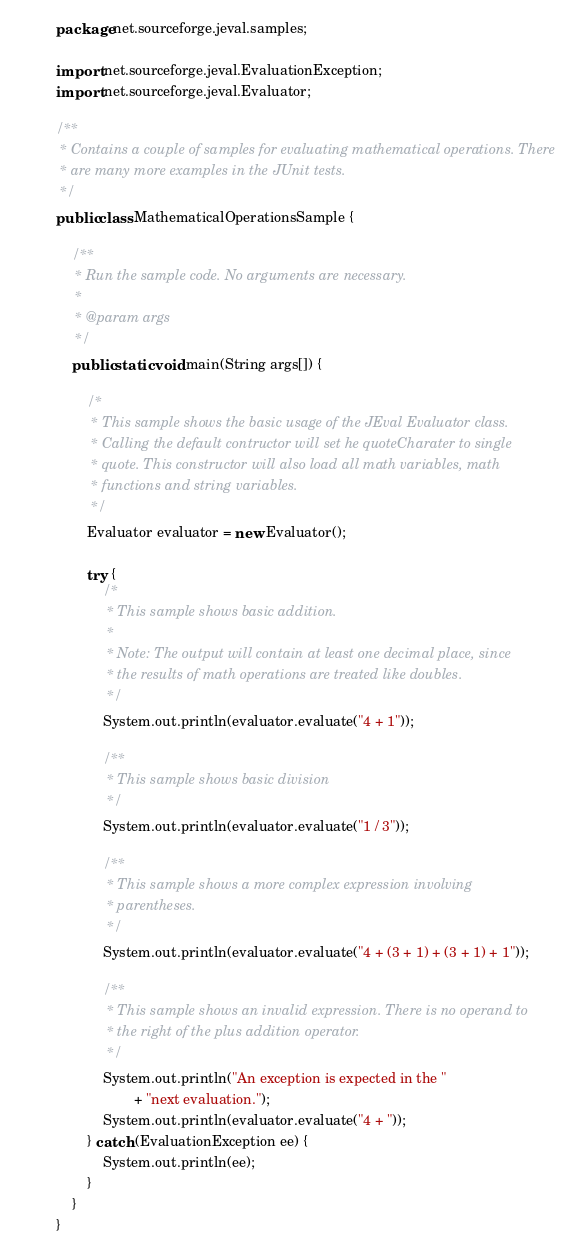Convert code to text. <code><loc_0><loc_0><loc_500><loc_500><_Java_>package net.sourceforge.jeval.samples;

import net.sourceforge.jeval.EvaluationException;
import net.sourceforge.jeval.Evaluator;

/**
 * Contains a couple of samples for evaluating mathematical operations. There
 * are many more examples in the JUnit tests.
 */
public class MathematicalOperationsSample {

	/**
	 * Run the sample code. No arguments are necessary.
	 * 
	 * @param args
	 */
	public static void main(String args[]) {

		/*
		 * This sample shows the basic usage of the JEval Evaluator class.
		 * Calling the default contructor will set he quoteCharater to single
		 * quote. This constructor will also load all math variables, math
		 * functions and string variables.
		 */
		Evaluator evaluator = new Evaluator();

		try {
			/*
			 * This sample shows basic addition.
			 * 
			 * Note: The output will contain at least one decimal place, since
			 * the results of math operations are treated like doubles.
			 */
			System.out.println(evaluator.evaluate("4 + 1"));

			/**
			 * This sample shows basic division
			 */
			System.out.println(evaluator.evaluate("1 / 3"));

			/**
			 * This sample shows a more complex expression involving
			 * parentheses.
			 */
			System.out.println(evaluator.evaluate("4 + (3 + 1) + (3 + 1) + 1"));

			/**
			 * This sample shows an invalid expression. There is no operand to
			 * the right of the plus addition operator.
			 */
			System.out.println("An exception is expected in the "
					+ "next evaluation.");
			System.out.println(evaluator.evaluate("4 + "));
		} catch (EvaluationException ee) {
			System.out.println(ee);
		}
	}
}
</code> 